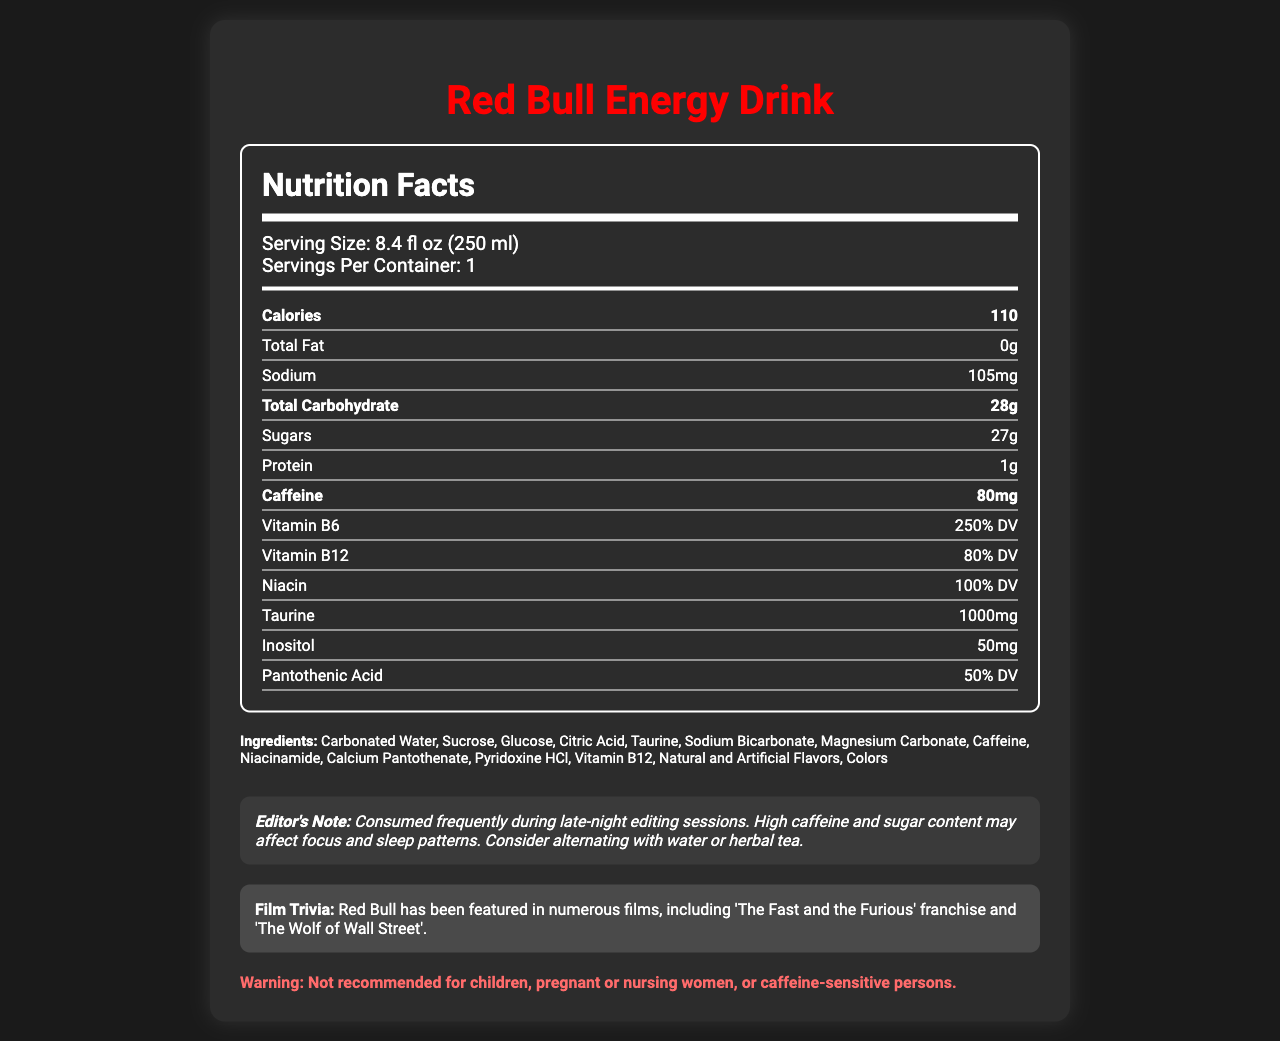what is the serving size of Red Bull Energy Drink? The serving size is listed as "8.4 fl oz (250 ml)" near the top of the Nutrition Facts section.
Answer: 8.4 fl oz (250 ml) how much caffeine is there in one serving of Red Bull Energy Drink? The amount of caffeine per serving is explicitly mentioned as "80mg" in the nutrient row labeled 'Caffeine'.
Answer: 80mg how many grams of sugar does Red Bull Energy Drink contain? The document states the total sugars are "27g" in the nutrient row labeled 'Sugars'.
Answer: 27g what percentage of the daily value does Vitamin B6 make up? The document lists Vitamin B6 as providing "250% DV" under the nutrient row labeled 'Vitamin B6'.
Answer: 250% DV What is the recommended pairing for Red Bull during movie marathons? The document's "recommended pairing" section suggests "pairs well with salty snacks like popcorn or pretzels during movie marathons".
Answer: Salty snacks like popcorn or pretzels How many calories are in one serving of Red Bull? A. 50 B. 70 C. 110 D. 150 The document states that each serving of Red Bull Energy Drink has "110 calories".
Answer: C. 110 How much sodium is there in a serving of Red Bull? A. 50mg B. 75mg C. 105mg D. 150mg The sodium content is listed as "105mg" per serving under the nutrient row labeled 'Sodium'.
Answer: C. 105mg Is Red Bull recommended for pregnant women? The document includes a warning stating that it is "Not recommended for children, pregnant or nursing women, or caffeine-sensitive persons".
Answer: No Summarize the information provided in this document regarding Red Bull Energy Drink. The document provides nutritional information, including caloric content, and caffeine and sugar levels, and notes vitamins and other ingredients. It includes consumption recommendations and trivia related to film appearances.
Answer: Red Bull Energy Drink is a popular caffeine-heavy beverage with 110 calories, 80mg of caffeine, and 27g of sugar per serving (8.4 fl oz). It's rich in vitamins B6, B12, and niacin and contains taurine and inositol. It is not recommended for children, pregnant or nursing women, or people sensitive to caffeine. It's often consumed during late-night sessions, pairs well with salty snacks, and has appeared in films like 'The Fast and the Furious'. how many grams of protein are there in Red Bull Energy Drink? The nutrient row labeled 'Protein' lists the protein content as "1g".
Answer: 1g what are the first three ingredients listed for Red Bull Energy Drink? The ingredients section lists "Carbonated Water, Sucrose, Glucose" as the first three ingredients.
Answer: Carbonated Water, Sucrose, Glucose Does Red Bull Energy Drink have any major allergens? The allergen information states "This product does not contain any major allergens".
Answer: No How much pantothenic acid does Red Bull contain as a percentage of the daily value? The document specifies that pantothenic acid makes up "50% DV" of the daily value.
Answer: 50% DV What is the purpose of the editor's note in the document? The editor's note emphasizes the impact of Red Bull's high caffeine and sugar content on focus and sleep, recommending alternatives like water or herbal tea.
Answer: To inform about the effect of high caffeine and sugar on focus and sleep patterns and suggest considering alternatives Which ingredient is not present in Red Bull Energy Drink? A. Citric Acid B. Magnesium Carbonate C. High Fructose Corn Syrup D. Niacinamide The listed ingredients do not include high fructose corn syrup; they do, however, include Citric Acid, Magnesium Carbonate, and Niacinamide.
Answer: C. High Fructose Corn Syrup How much taurine is in one serving of Red Bull Energy Drink? The document states that one serving contains "1000mg" of taurine.
Answer: 1000mg What is the percentage of the daily value for niacin in Red Bull? The niacin content is listed as "100% DV" on the nutrient row labeled 'Niacin'.
Answer: 100% DV In which films has Red Bull been featured? The film trivia section mentions "The Fast and the Furious franchise and 'The Wolf of Wall Street'".
Answer: The Fast and the Furious franchise and The Wolf of Wall Street Could the taurine in Red Bull affect someone's editing performance? The document does not provide information regarding the impact of taurine on editing performance.
Answer: Cannot be determined 